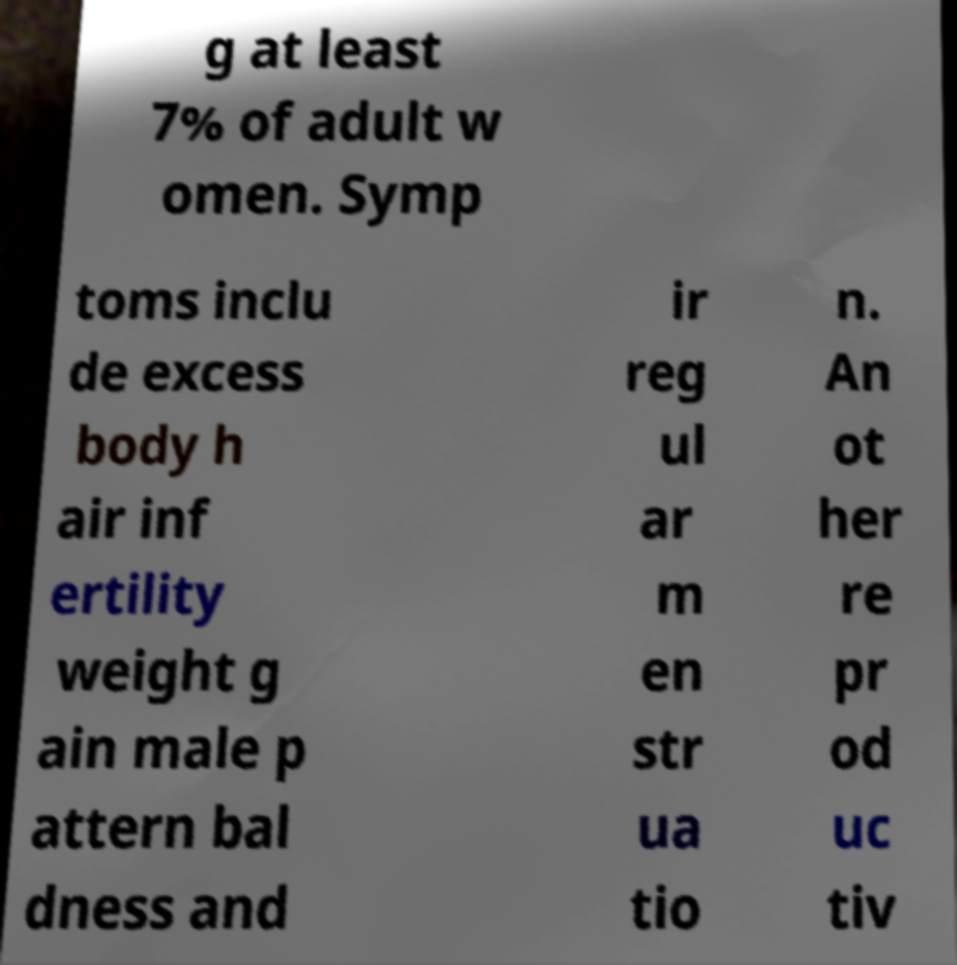Please read and relay the text visible in this image. What does it say? g at least 7% of adult w omen. Symp toms inclu de excess body h air inf ertility weight g ain male p attern bal dness and ir reg ul ar m en str ua tio n. An ot her re pr od uc tiv 